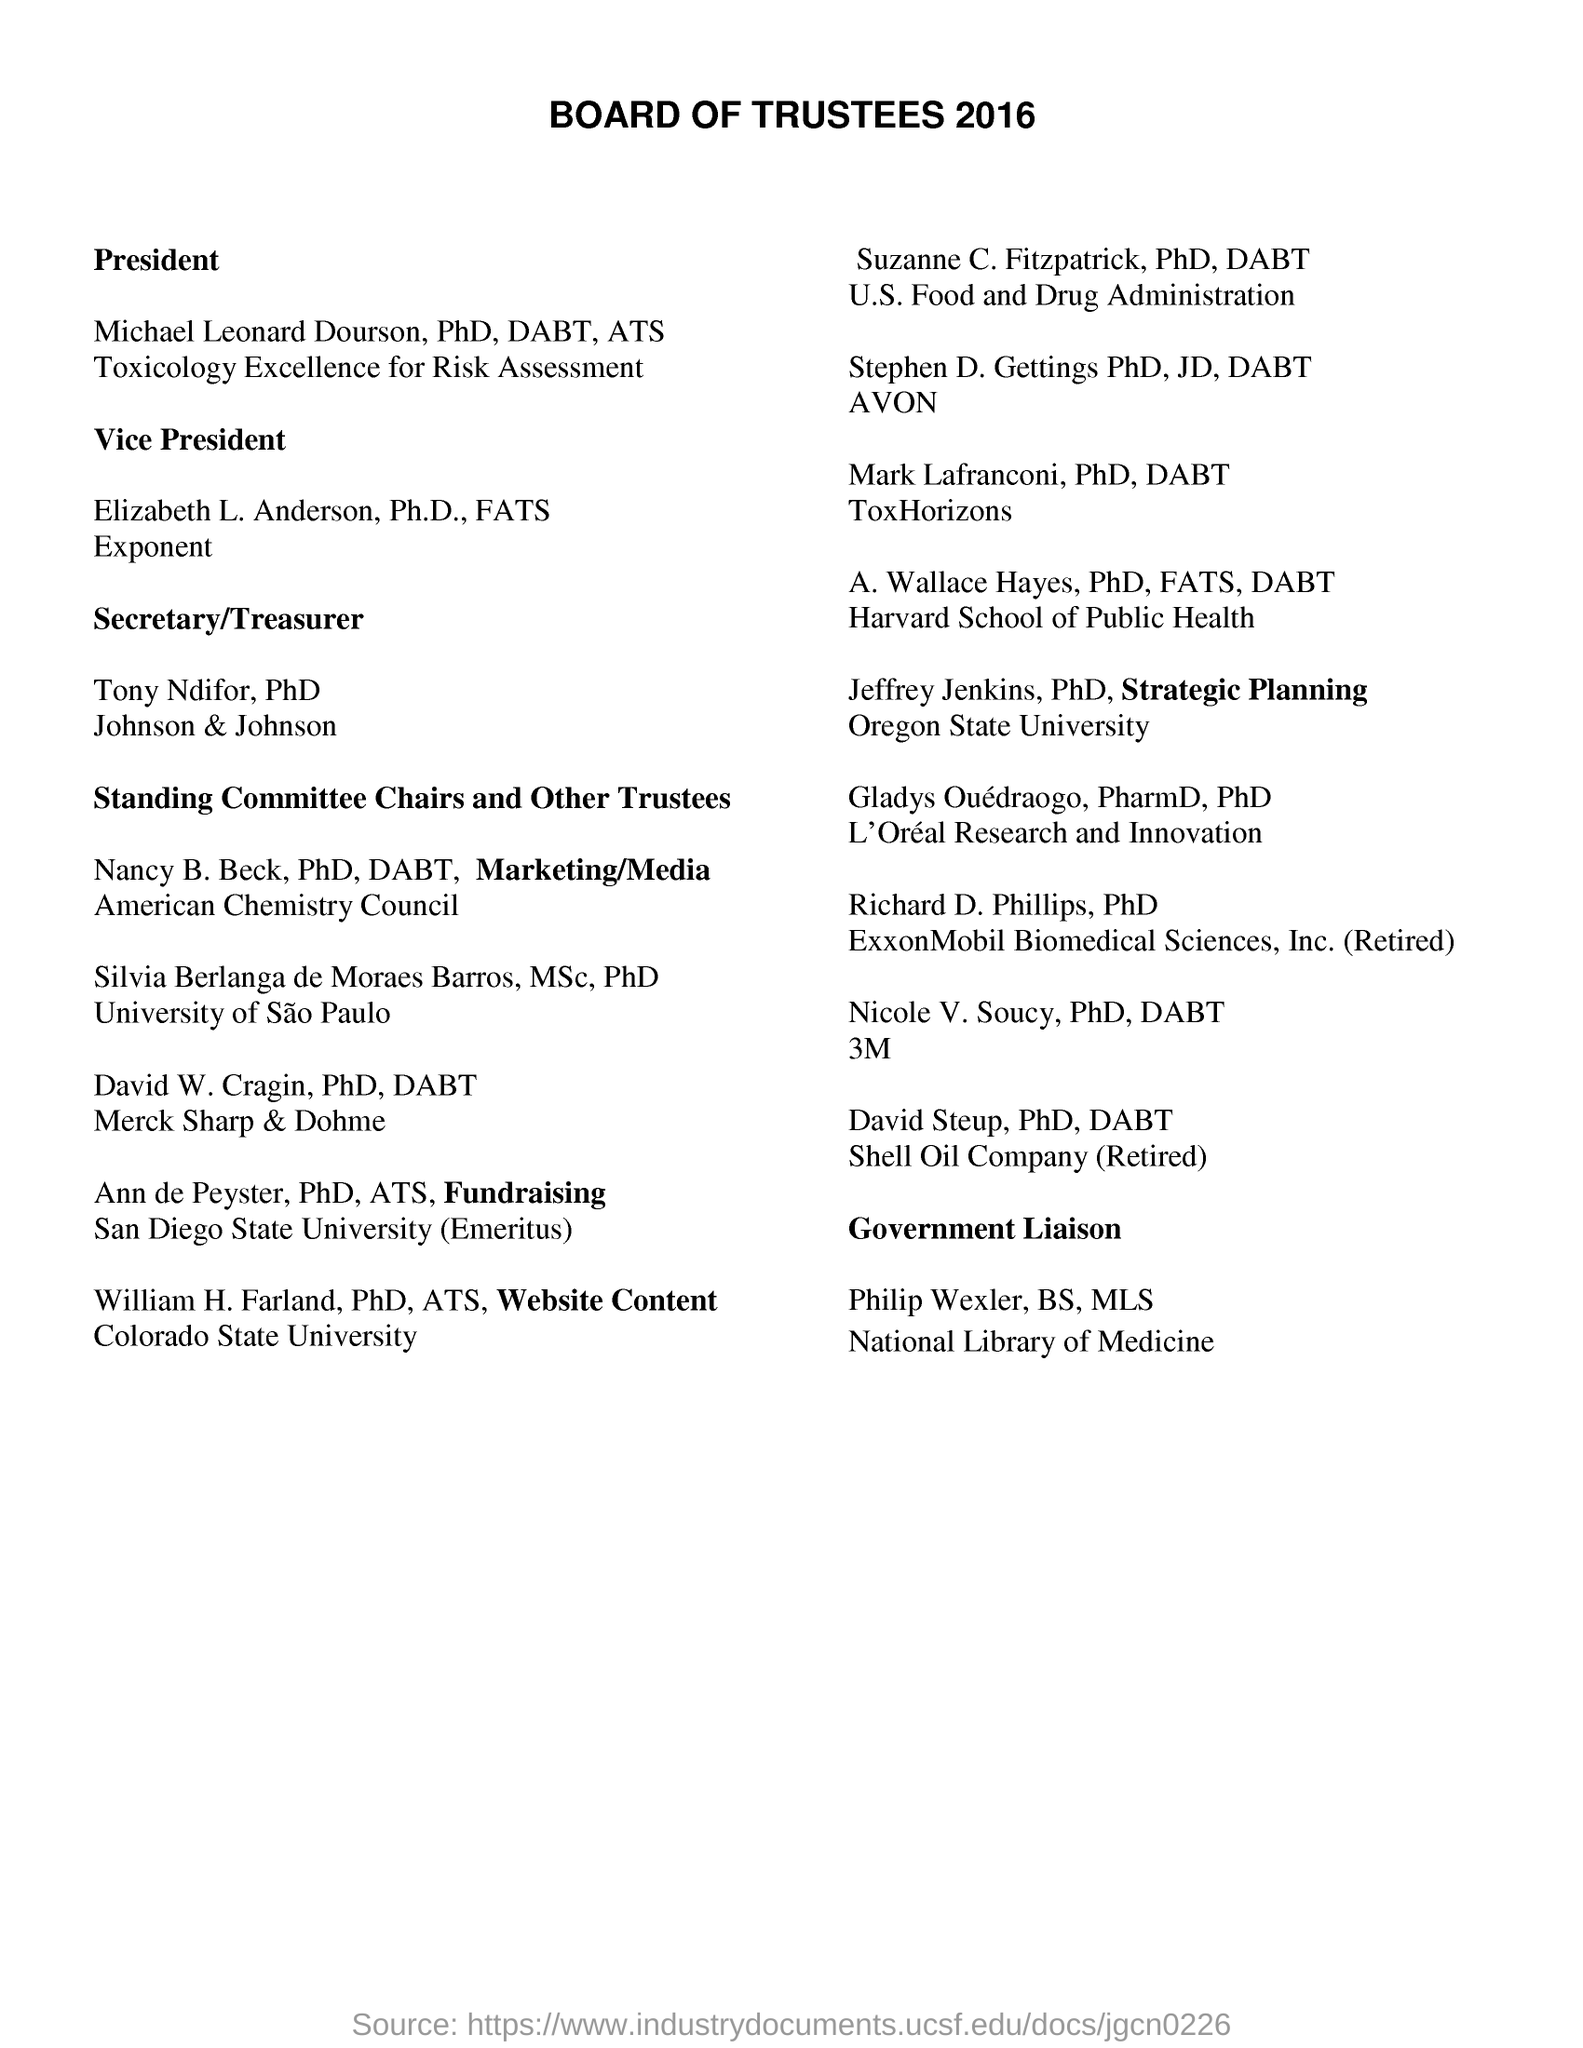What is the name of the President of BOARD OF TRUSTEES?
Your response must be concise. Michael Leonard Dourson. To which university did William H. Farland belong to?
Ensure brevity in your answer.  Colorado State University. 